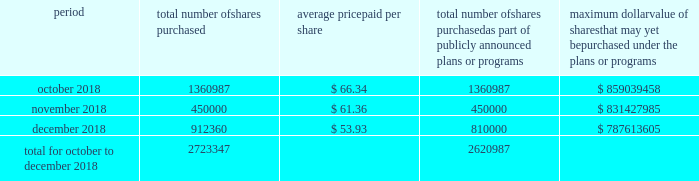Table of content part ii item 5 .
Market for the registrant's common equity , related stockholder matters and issuer purchases of equity securities our common stock is traded on the new york stock exchange under the trading symbol 201chfc . 201d in september 2018 , our board of directors approved a $ 1 billion share repurchase program , which replaced all existing share repurchase programs , authorizing us to repurchase common stock in the open market or through privately negotiated transactions .
The timing and amount of stock repurchases will depend on market conditions and corporate , regulatory and other relevant considerations .
This program may be discontinued at any time by the board of directors .
The table includes repurchases made under this program during the fourth quarter of 2018 .
Period total number of shares purchased average price paid per share total number of shares purchased as part of publicly announced plans or programs maximum dollar value of shares that may yet be purchased under the plans or programs .
During the quarter ended december 31 , 2018 , 102360 shares were withheld from certain executives and employees under the terms of our share-based compensation agreements to provide funds for the payment of payroll and income taxes due at vesting of restricted stock awards .
As of february 13 , 2019 , we had approximately 97419 stockholders , including beneficial owners holding shares in street name .
We intend to consider the declaration of a dividend on a quarterly basis , although there is no assurance as to future dividends since they are dependent upon future earnings , capital requirements , our financial condition and other factors. .
For the quarter ended december 312018 what was the percentage of shares acquired in december? 
Computations: (912360 / 2723347)
Answer: 0.33501. 